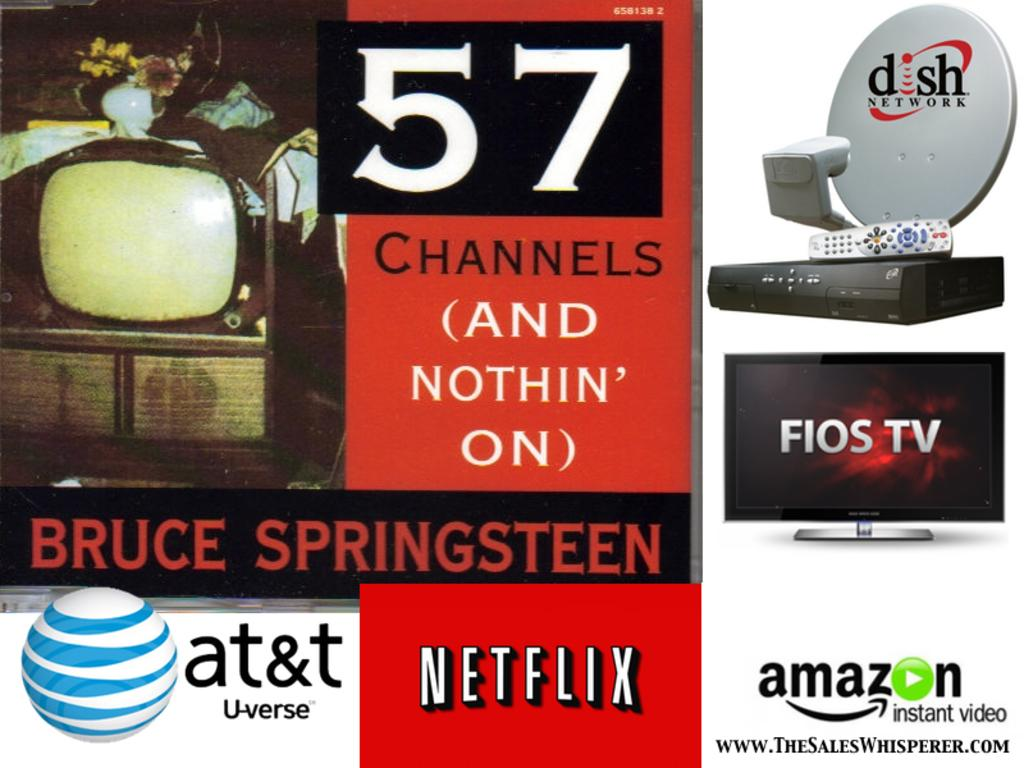<image>
Share a concise interpretation of the image provided. Logos for AT&T, Netflix, Amazon, Fios, and Dish surround the text "57 channels (and nothin' on)". 